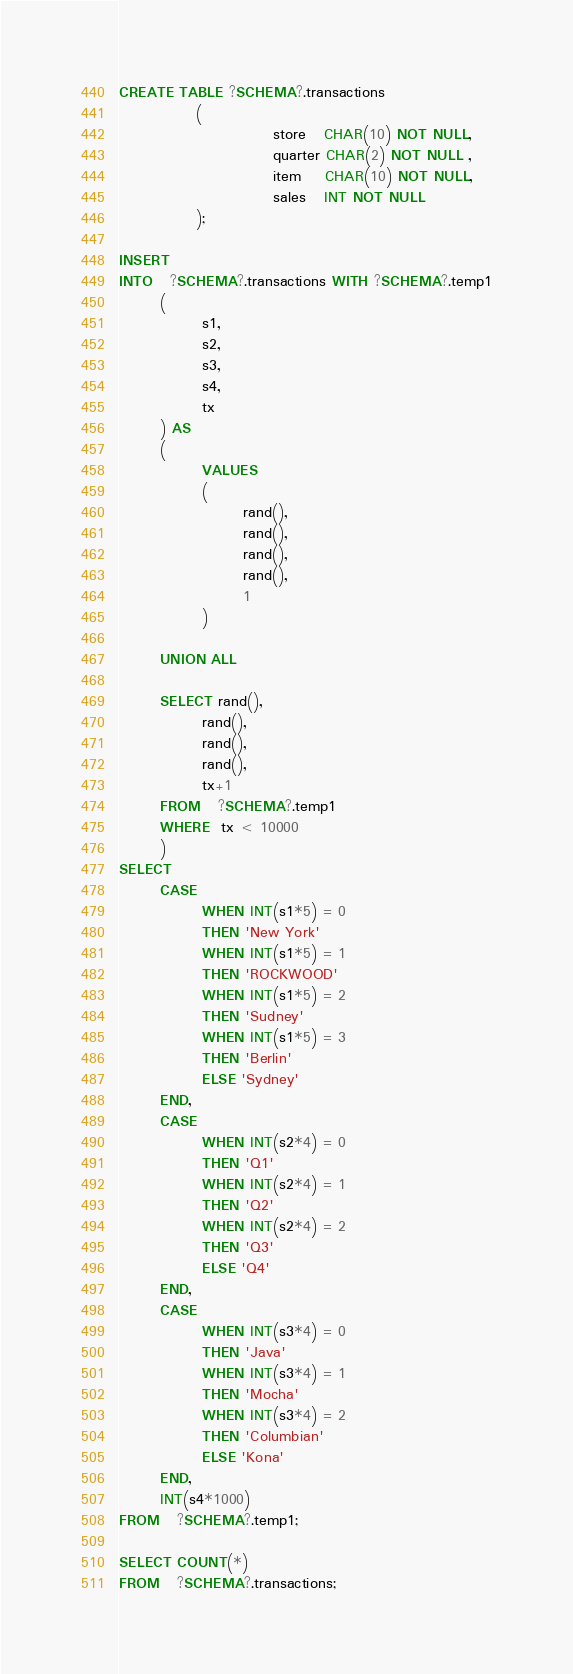Convert code to text. <code><loc_0><loc_0><loc_500><loc_500><_SQL_>CREATE TABLE ?SCHEMA?.transactions
             (
                          store   CHAR(10) NOT NULL,
                          quarter CHAR(2) NOT NULL ,
                          item    CHAR(10) NOT NULL,
                          sales   INT NOT NULL
             );

INSERT
INTO   ?SCHEMA?.transactions WITH ?SCHEMA?.temp1
       (
              s1,
              s2,
              s3,
              s4,
              tx
       ) AS
       (
              VALUES
              (
                     rand(),
                     rand(),
                     rand(),
                     rand(),
                     1
              )
       
       UNION ALL
       
       SELECT rand(),
              rand(),
              rand(),
              rand(),
              tx+1
       FROM   ?SCHEMA?.temp1
       WHERE  tx < 10000
       )
SELECT
       CASE
              WHEN INT(s1*5) = 0
              THEN 'New York'
              WHEN INT(s1*5) = 1
              THEN 'ROCKWOOD'
              WHEN INT(s1*5) = 2
              THEN 'Sudney'
              WHEN INT(s1*5) = 3
              THEN 'Berlin'
              ELSE 'Sydney'
       END,
       CASE
              WHEN INT(s2*4) = 0
              THEN 'Q1'
              WHEN INT(s2*4) = 1
              THEN 'Q2'
              WHEN INT(s2*4) = 2
              THEN 'Q3'
              ELSE 'Q4'
       END,
       CASE
              WHEN INT(s3*4) = 0
              THEN 'Java'
              WHEN INT(s3*4) = 1
              THEN 'Mocha'
              WHEN INT(s3*4) = 2
              THEN 'Columbian'
              ELSE 'Kona'
       END,
       INT(s4*1000)
FROM   ?SCHEMA?.temp1;

SELECT COUNT(*)
FROM   ?SCHEMA?.transactions;
</code> 